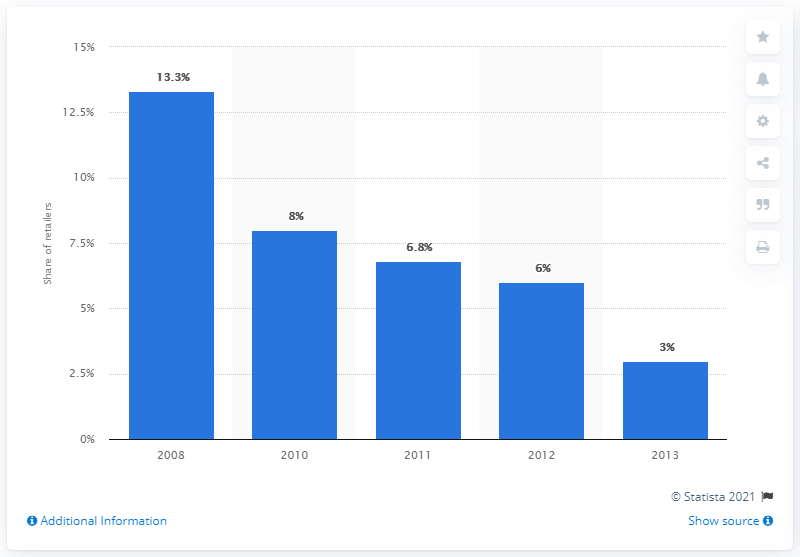Point out several critical features in this image. In 2013, a significant percentage of leading online retailers offered delivery gift wrapping as a service. 